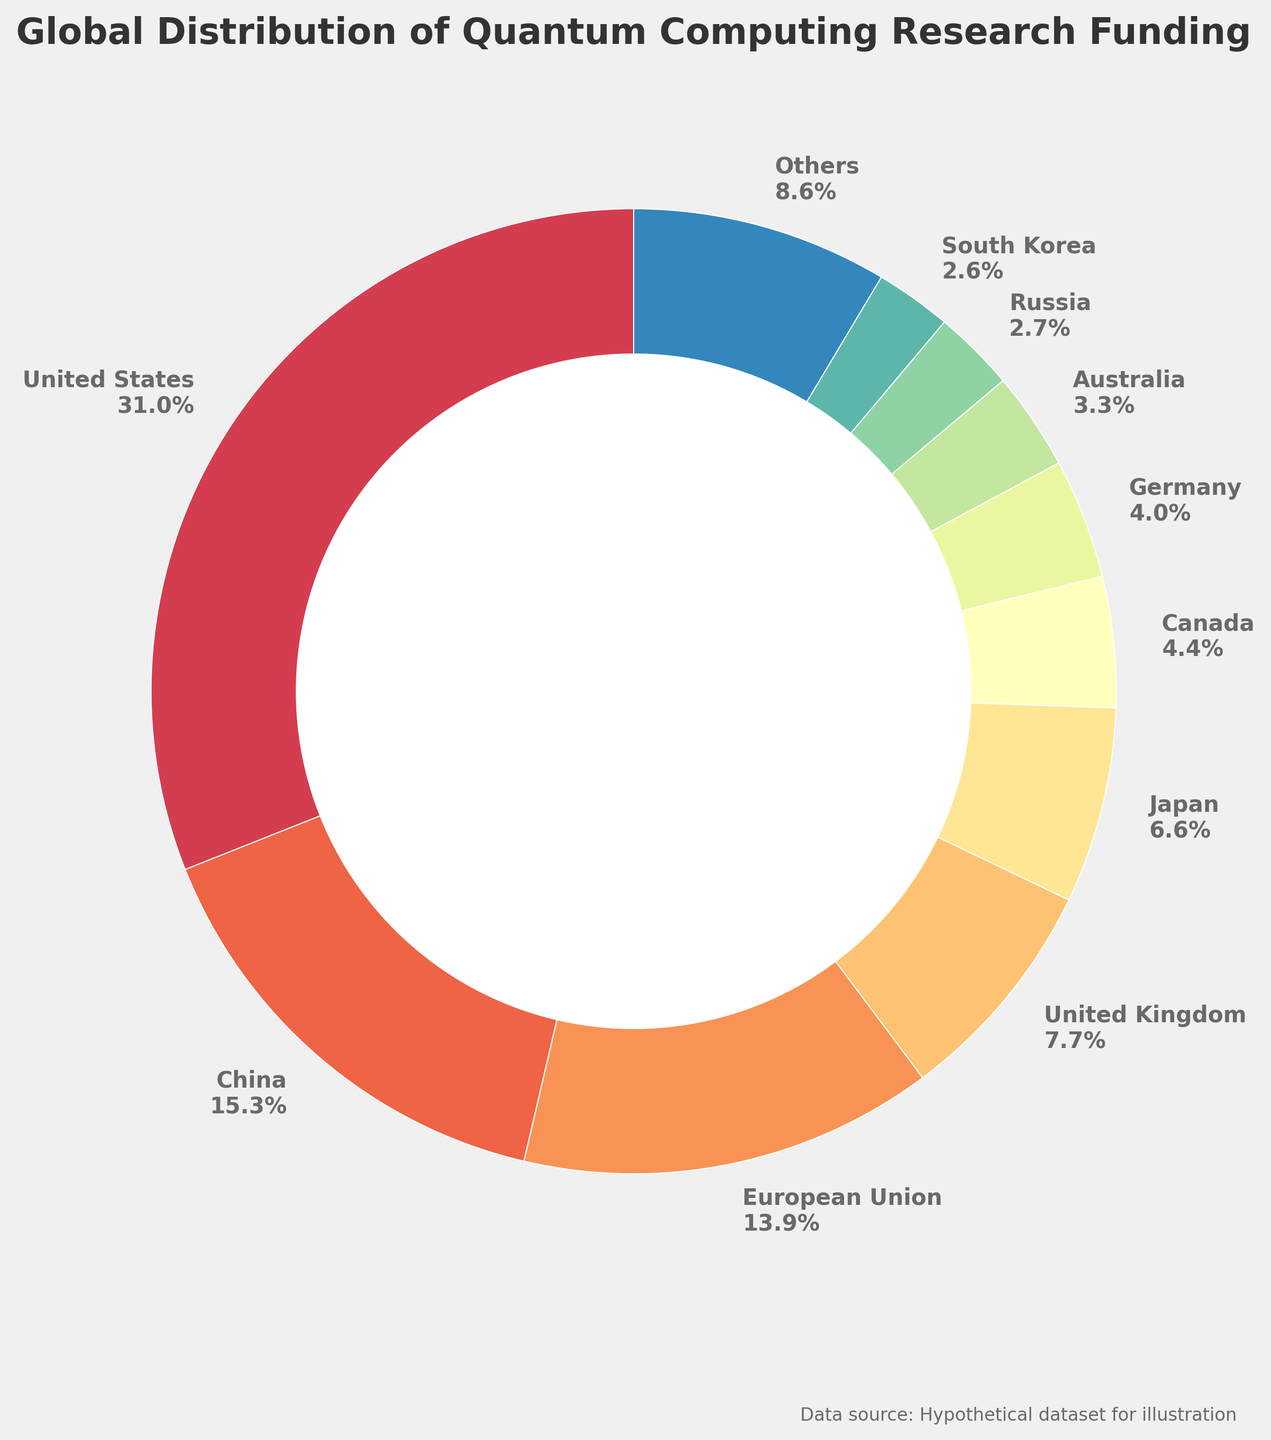What is the percentage of quantum computing research funding for the United States? The label corresponding to the United States shows the percentage of the total funding.
Answer: 36.7% Which country has the second-highest quantum computing research funding? By examining the pie chart, we see that China has the second-largest slice after the United States.
Answer: China What is the combined funding percentage of Japan and Canada? From the pie chart, Japan has a funding percentage of 7.8%, and Canada has 5.2%. Adding these together gives us 7.8% + 5.2% = 13.0%.
Answer: 13.0% How does the funding of the United Kingdom compare to that of Japan? The label for the United Kingdom shows 9.1%, while Japan has 7.8%. Therefore, the United Kingdom has a higher funding percentage than Japan.
Answer: United Kingdom has a higher funding percentage What is the total percentage of quantum computing research funding for all countries except the top 10? The 'Others' segment of the pie chart shows the aggregated funding percentage for countries outside the top 10, which is 6.1%.
Answer: 6.1% Which countries have funding percentages lower than 5%? By examining the pie chart labels, the countries with funding percentages lower than 5% are Russia (3.2%), South Korea (3.0%), India (2.8%), Netherlands (2.2%), Switzerland (2.0%), Singapore (1.7%), and Israel (1.5%).
Answer: Russia, South Korea, India, Netherlands, Switzerland, Singapore, Israel How much more funding does the United States receive compared to the European Union? The pie chart shows that the United States receives 36.7% of the funding, whereas the European Union receives 16.4%. The difference in funding percentages is 36.7% - 16.4% = 20.3%.
Answer: 20.3% What color represents Australia in the pie chart? By looking at the color legends or segments carefully matched with Australia, we can identify its specific color in the pie chart.
Answer: The specific segment's color for Australia Which regions or countries combined make up roughly half of the global funding? The funding percentages for the United States (36.7%) and China (18.1%) sum up to 54.8%. This covers more than half of the total funding.
Answer: United States and China 